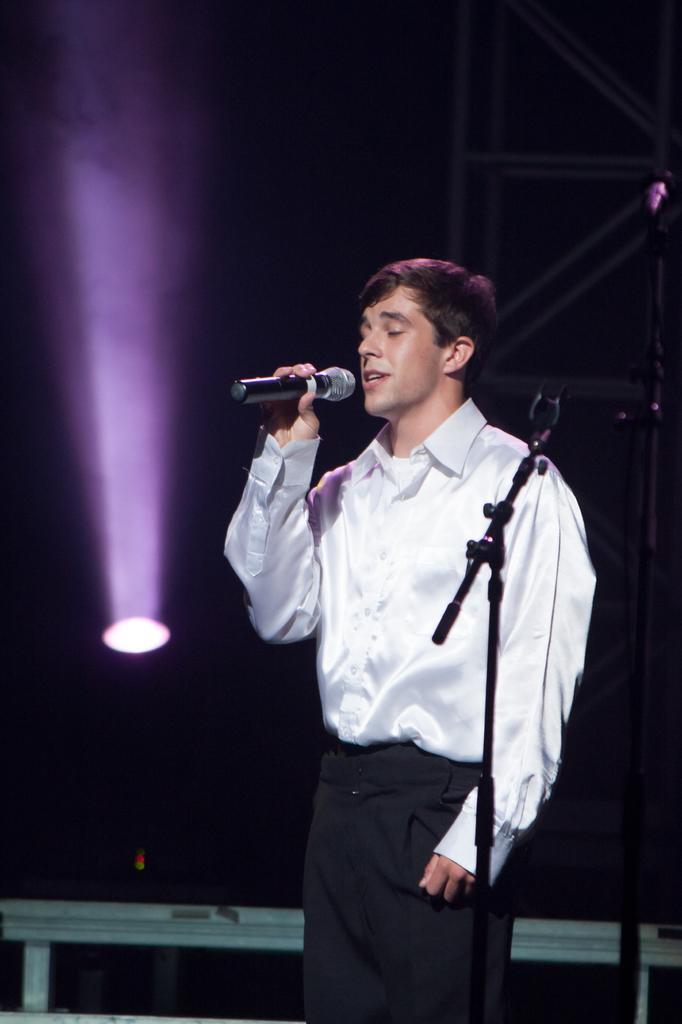Please provide a concise description of this image. This image is clicked in a hall. There is a man, who is wearing white shirt and black pant. He is singing in the mic. In front of him there is a mic stand. In the background, there is a focused light stand. 